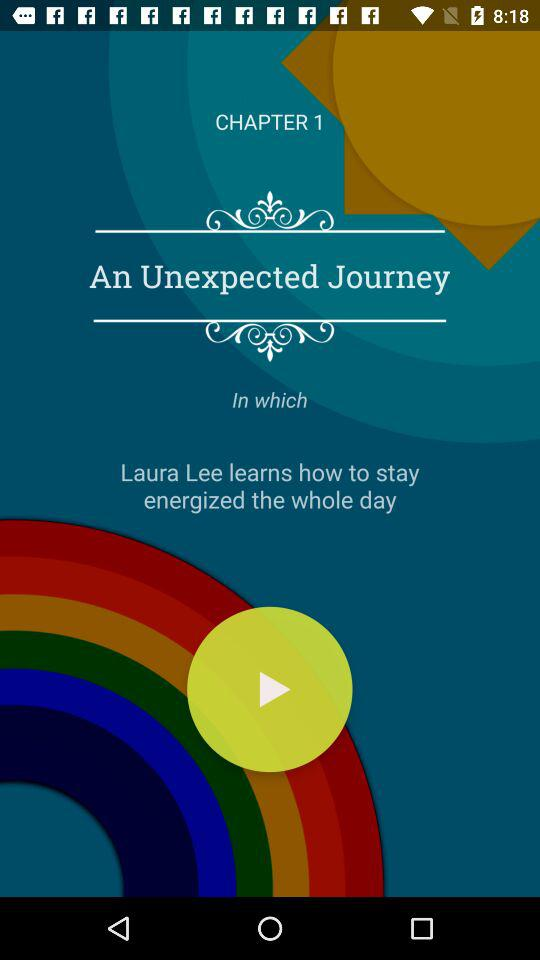How many chapters in total are there?
When the provided information is insufficient, respond with <no answer>. <no answer> 